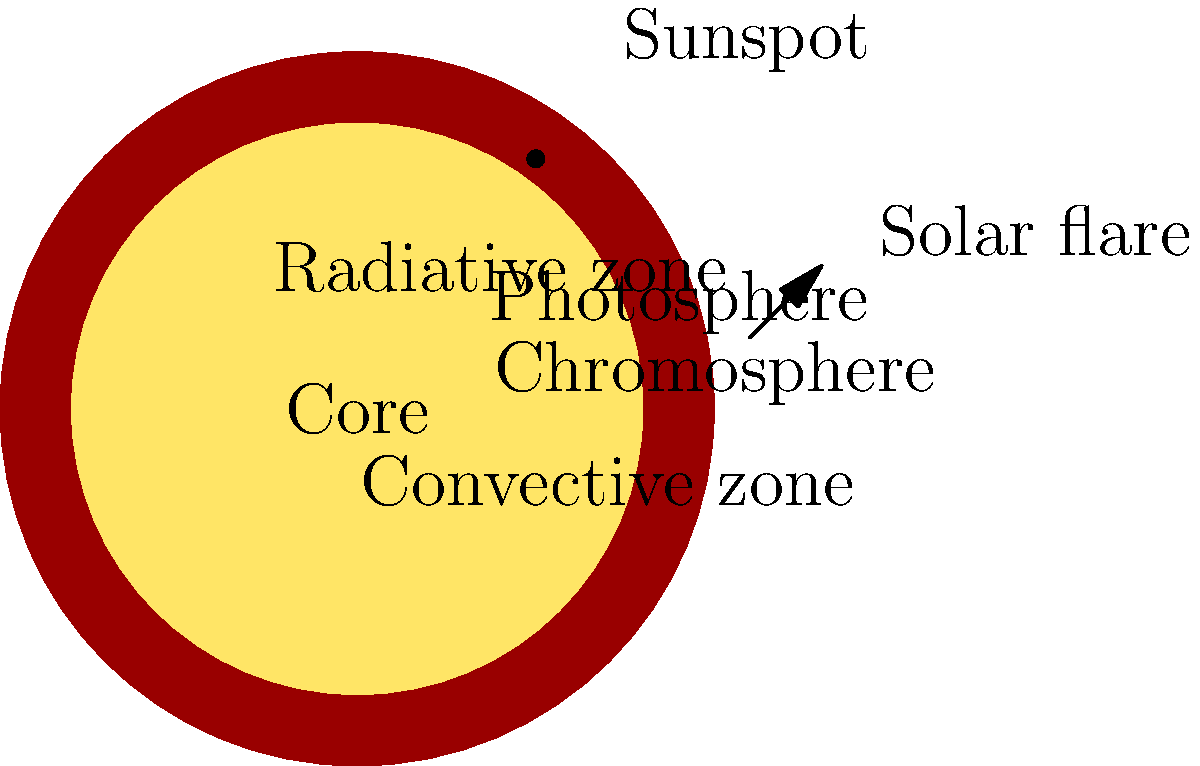In your latest novel, you're describing a character who's an astrophysicist explaining the Sun's structure to their child. Which layer of the Sun is responsible for the energy transport mechanism that creates the cellular patterns visible on the Sun's surface, and what are these patterns called? To answer this question, let's break down the Sun's structure from the inside out:

1. Core: The innermost layer where nuclear fusion occurs.
2. Radiative zone: Energy is transported outward through radiation.
3. Convective zone: Energy is transported through convection.
4. Photosphere: The visible "surface" of the Sun.
5. Chromosphere: A thin layer above the photosphere.
6. Corona: The outermost layer of the Sun's atmosphere.

The key to this question lies in the convective zone. Here's why:

1. In the convective zone, hot plasma rises to the surface, cools, and then sinks back down.
2. This convection process creates cellular patterns on the Sun's surface.
3. These patterns are called "granules" and form a granulation pattern.
4. Granules are small (about 1,000 km across) and short-lived (about 20 minutes).
5. Larger patterns called supergranules (about 30,000 km across) also exist and last longer.

The convective zone is responsible for this energy transport mechanism, which results in the visible cellular patterns (granules and supergranules) on the Sun's surface.
Answer: Convective zone; granules 